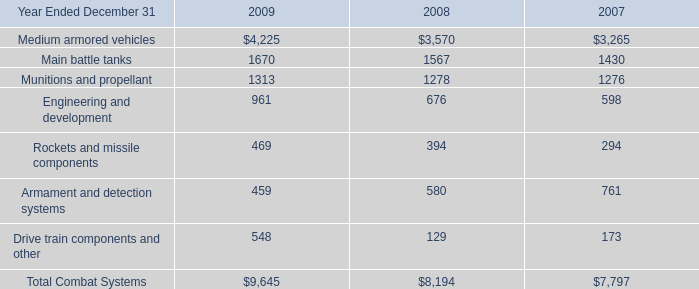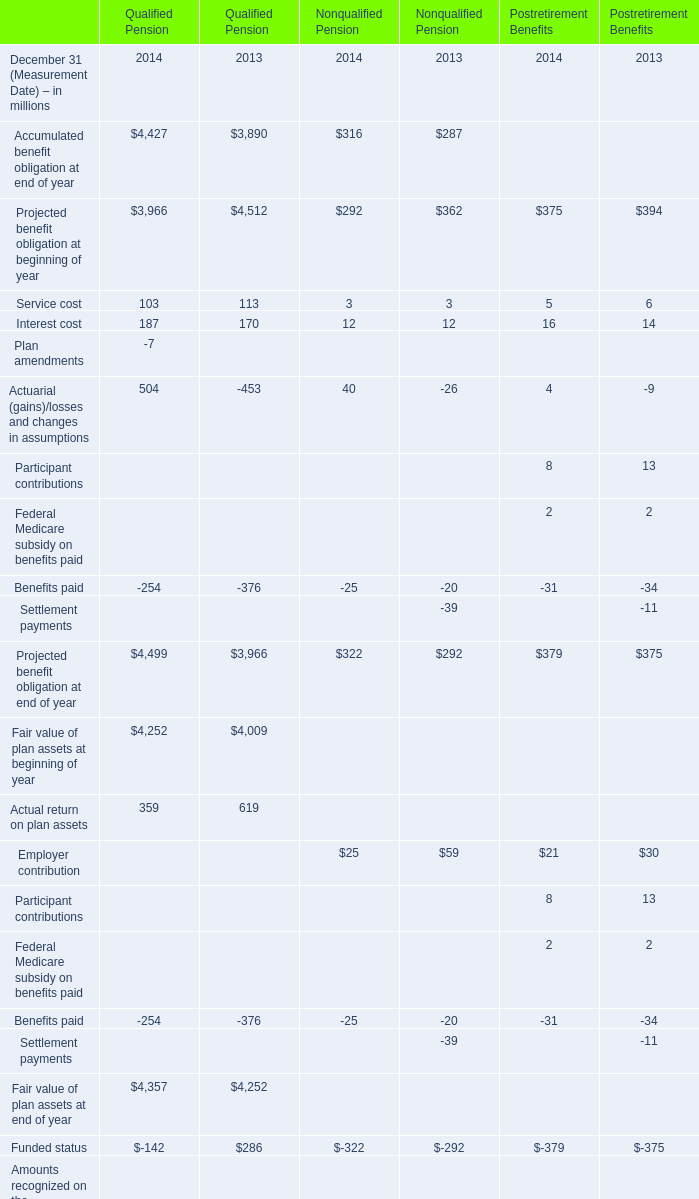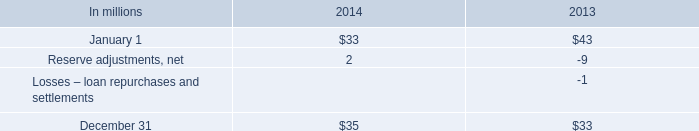What is the total value of Service cost, Interest cost,Plan amendments and Actuarial (gains)/losses and changes in assumptions in 2014 for Qualified Pension? (in million) 
Computations: (((103 + 187) - 7) + 504)
Answer: 787.0. 